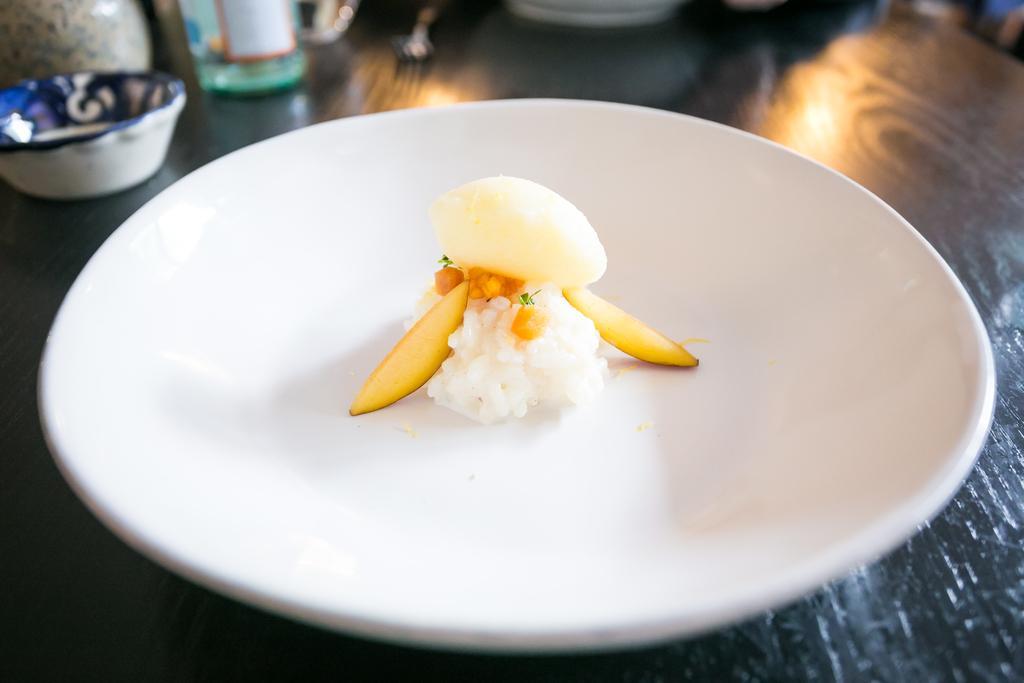In one or two sentences, can you explain what this image depicts? In this image I can see a black colored table and on it I can see a plate which is white in color. In the plate I can see a food item which is white, cream, yellow and orange in color. I can see few other objects on the table. 